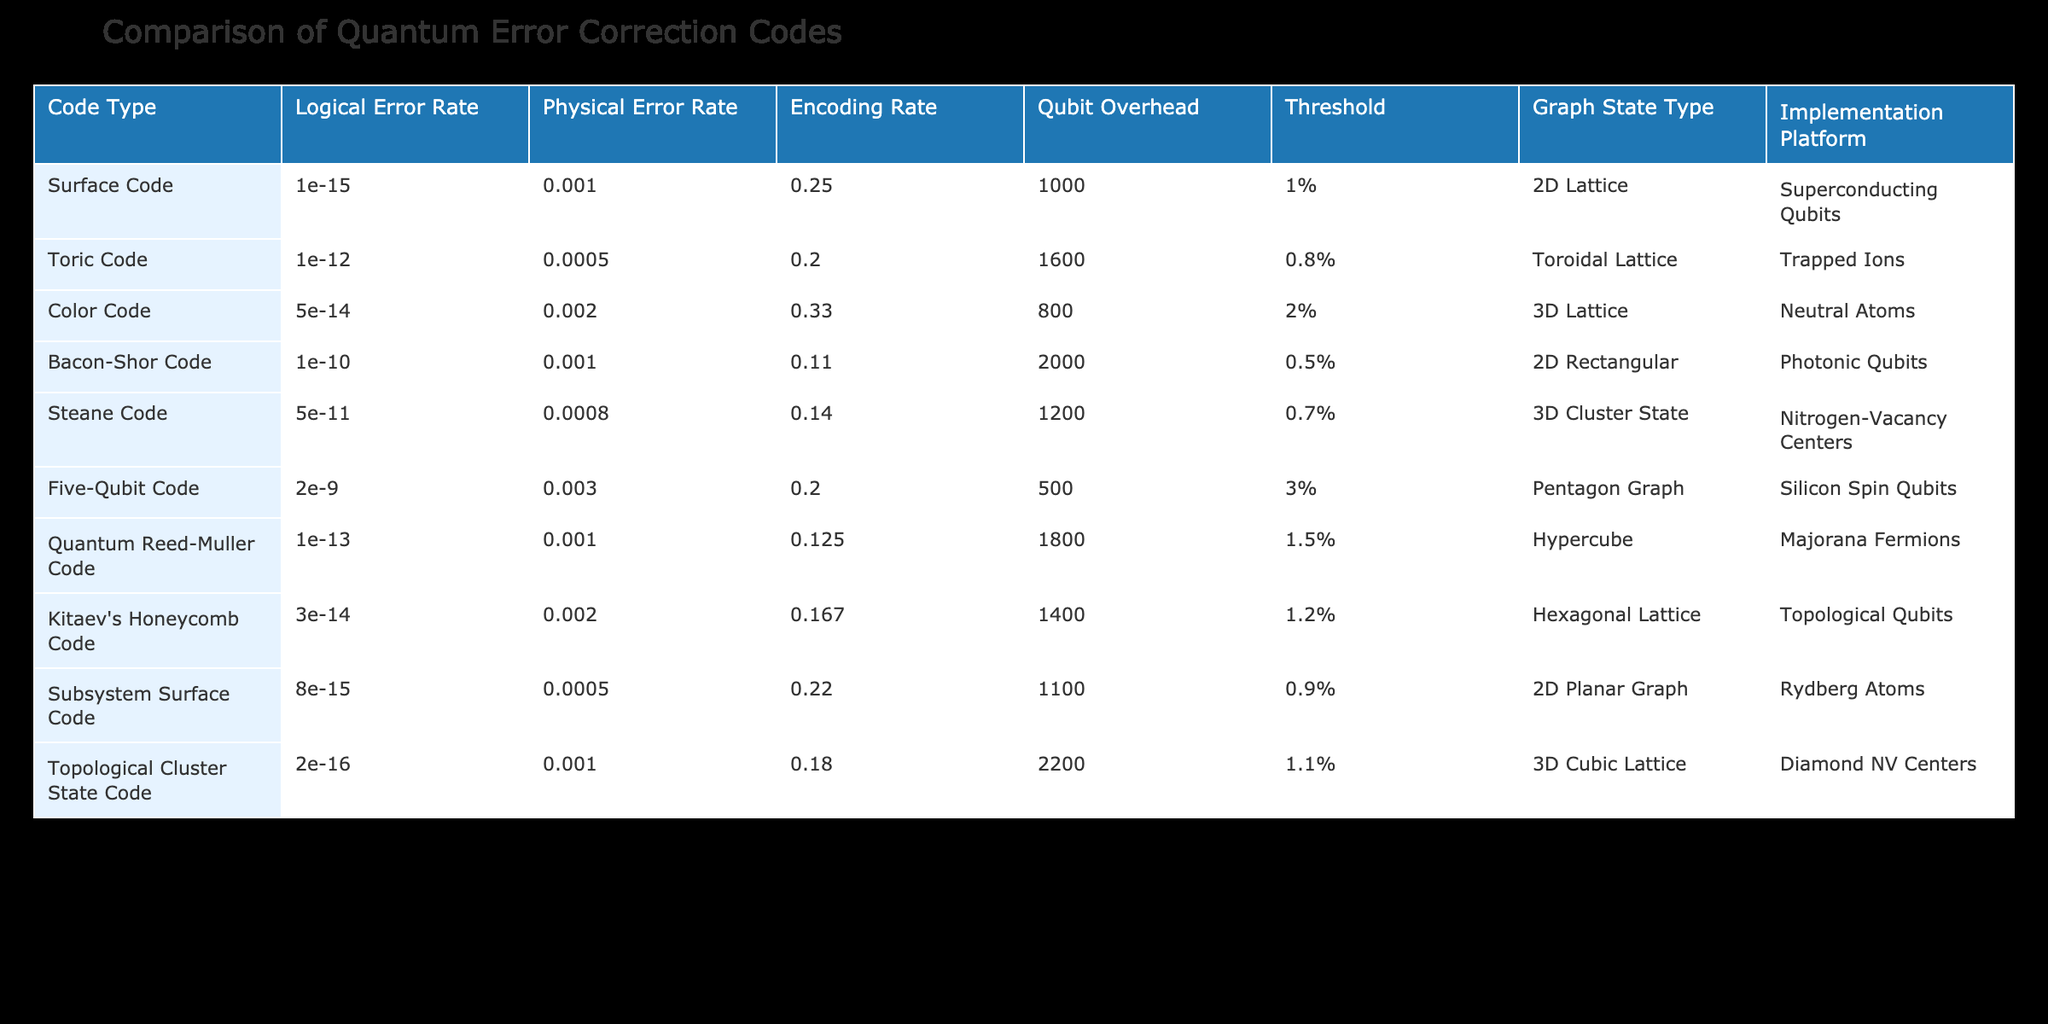What is the logical error rate of the Surface Code? The logical error rate for the Surface Code can be directly found in the appropriate column labeled "Logical Error Rate," which shows a value of 1e-15.
Answer: 1e-15 Which code has the highest physical error rate? By examining the "Physical Error Rate" column, we see that the Five-Qubit Code has the highest value at 3e-3 compared to other codes.
Answer: 3e-3 Is the encoding rate of the Color Code greater than that of the Toric Code? The encoding rate for the Color Code is 0.33, while for the Toric Code it is 0.2. Since 0.33 is greater than 0.2, the statement is true.
Answer: Yes What is the average qubit overhead of the codes listed? The qubit overheads of the codes are: 1000, 1600, 800, 2000, 1200, 500, 1800, 1400, 1100, and 2200. Summing these gives a total of 10300. Dividing by 10 (the number of codes) results in an average of 1030.
Answer: 1030 Which code has the lowest threshold and what is its value? Upon reviewing the "Threshold" column, we find that the Bacon-Shor Code has the lowest threshold at 0.5%.
Answer: 0.5% Are all the codes based on 2D or 3D graph states? The table shows that some codes are based on 2D (e.g., Surface Code, Bacon-Shor Code, Subsystem Surface Code) while others use 3D (e.g., Color Code, Steane Code, Topological Cluster State Code). Therefore, not all are from the same dimensions as there is a mix of both.
Answer: No What is the difference in qubit overhead between the Topological Cluster State Code and the Five-Qubit Code? The qubit overhead of the Topological Cluster State Code is 2200, while the Five-Qubit Code has an overhead of 500. The difference is calculated as 2200 - 500 = 1700.
Answer: 1700 Which code has the highest encoding rate and what is that rate? Examining the "Encoding Rate" column, the highest value is 0.33 for the Color Code. This indicates that the Color Code has the best encoding efficiency among the listed codes.
Answer: 0.33 Is there any code that has a physical error rate below 1e-3? Looking at the "Physical Error Rate" column, both the Surface Code and the Toric Code have error rates below 1e-3 (1e-3 and 5e-4, respectively). Therefore, the statement is true; there are codes with error rates below this threshold.
Answer: Yes 